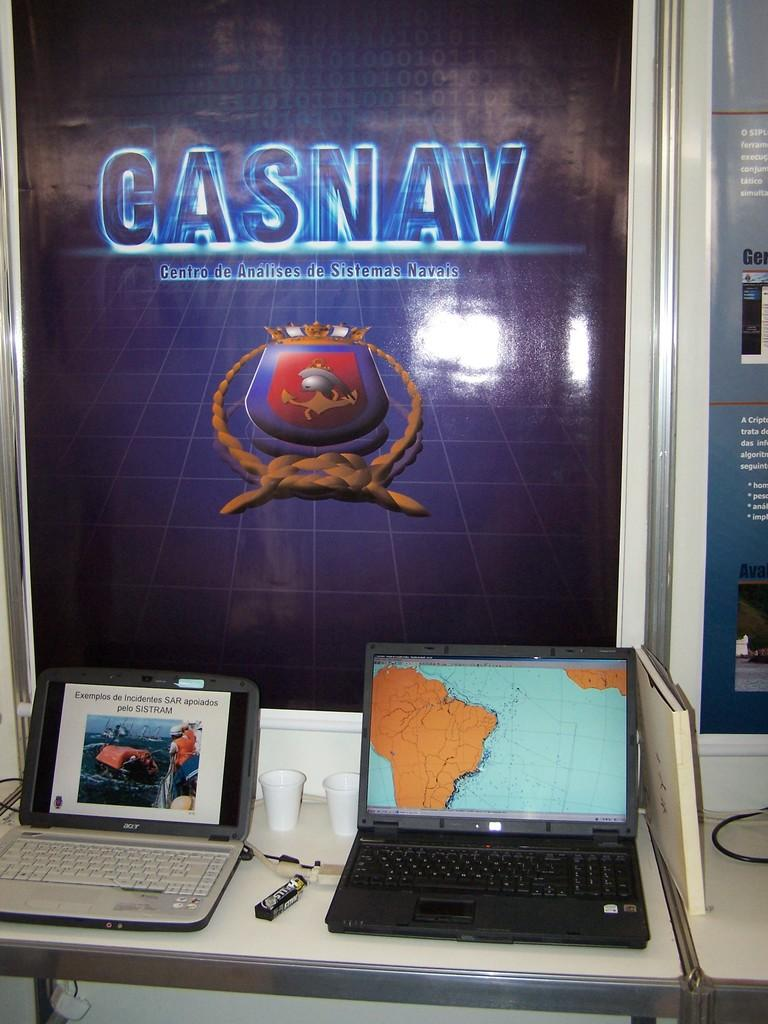Provide a one-sentence caption for the provided image. Two laptops are sitting underneath a large Gasnav poster. 